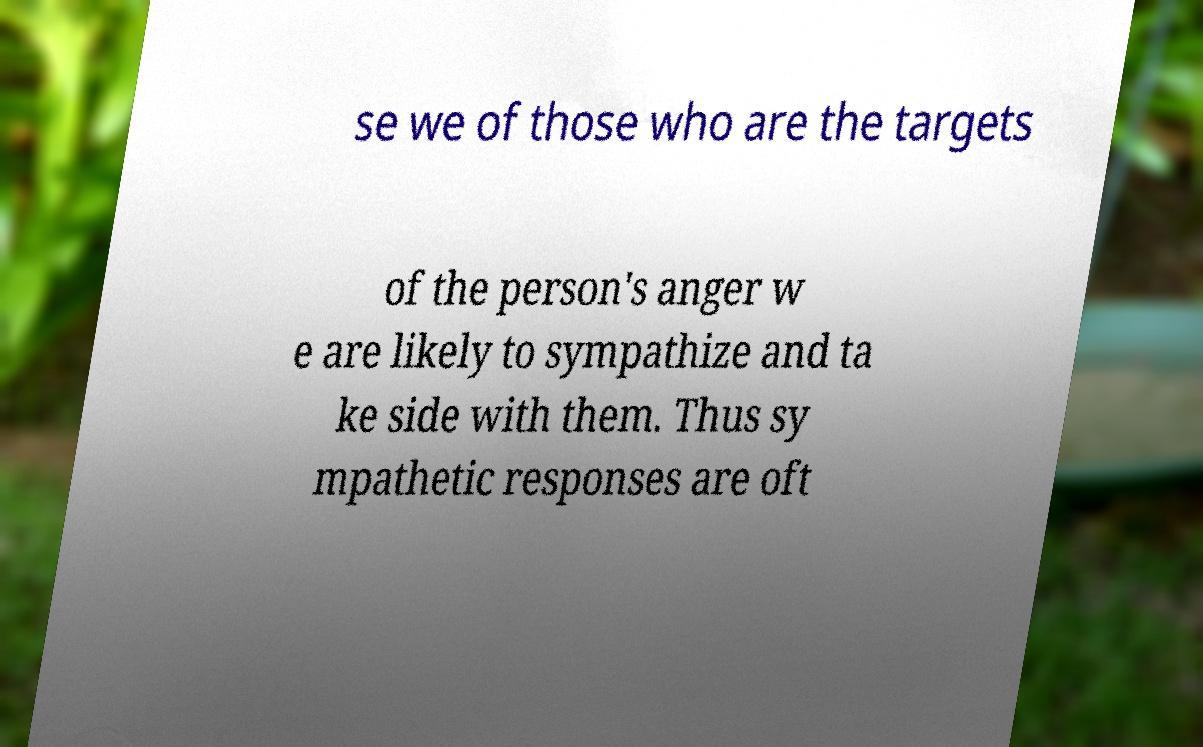Please identify and transcribe the text found in this image. se we of those who are the targets of the person's anger w e are likely to sympathize and ta ke side with them. Thus sy mpathetic responses are oft 